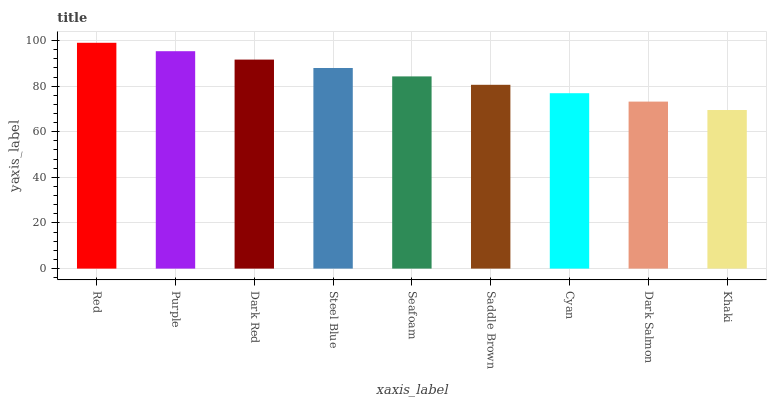Is Khaki the minimum?
Answer yes or no. Yes. Is Red the maximum?
Answer yes or no. Yes. Is Purple the minimum?
Answer yes or no. No. Is Purple the maximum?
Answer yes or no. No. Is Red greater than Purple?
Answer yes or no. Yes. Is Purple less than Red?
Answer yes or no. Yes. Is Purple greater than Red?
Answer yes or no. No. Is Red less than Purple?
Answer yes or no. No. Is Seafoam the high median?
Answer yes or no. Yes. Is Seafoam the low median?
Answer yes or no. Yes. Is Purple the high median?
Answer yes or no. No. Is Khaki the low median?
Answer yes or no. No. 